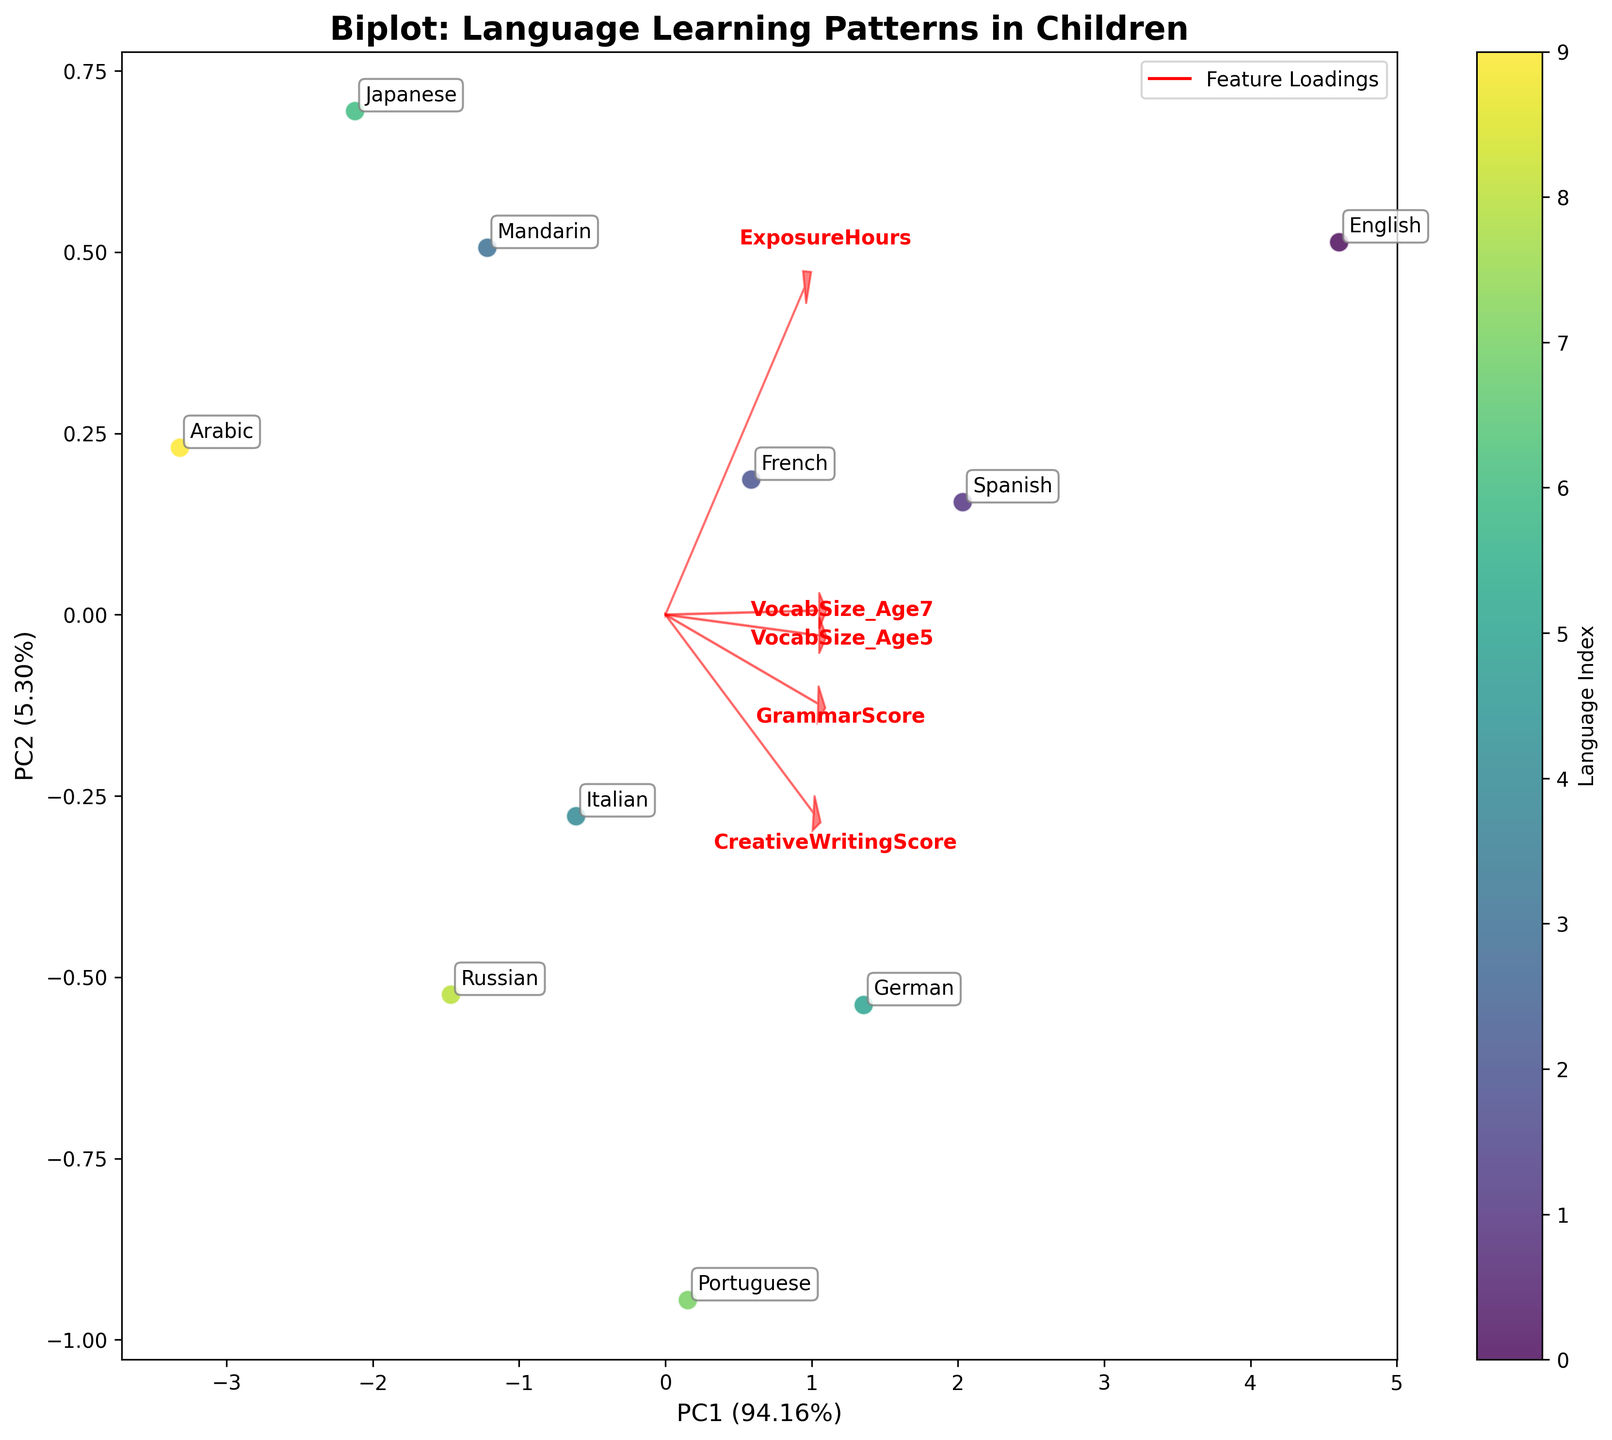what is the title of the figure? The title is located at the top of the figure, which describes the overall content or main point of the visual. It is written in bold for emphasis.
Answer: Biplot: Language Learning Patterns in Children Which language has the highest value on PC1? By observing the x-axis (PC1), identify the data point that is farthest to the right. The label for this data point reveals the language.
Answer: English What is the percentage of variance explained by PC1 and PC2 altogether? Sum the percentages shown in the axis labels for PC1 and PC2. PC1 and PC2 labels provide variance percentages.
Answer: 58.54% How are GrammarScore and CreativeWritingScore related according to the biplot loadings? Follow the arrows representing the GrammarScore and CreativeWritingScore loadings. See if they point in similar or different directions to understand their correlation.
Answer: Positively Correlated Which languages show a lower value in PC2 according to the Biplot? Check the y-axis (PC2), and identify labels at the bottom-most part for negative PC2 values.
Answer: Arabic and Japanese Which feature contributes the most to PC1? Examine the lengths of the arrows representing loadings for PC1. The longest arrow towards the x-axis has the maximum contribution.
Answer: ExposureHours How much variance is explained by the second principal component (PC2)? Look at the y-axis label. The percentage indicating the explained variance by PC2 is presented there.
Answer: 23.48% What can be inferred about Mandarin and Russian based on their positions in the biplot? Compare the positions of Mandarin and Russian data points along PC1 and PC2. Determine similarities or differences in their PCA scores.
Answer: Similar PC1, different PC2 Do VocabSize_Age5 and VocabSize_Age7 load similarly on the principal components? Review the direction and length of the arrows for VocabSize_Age5 and VocabSize_Age7. Check if they align closely, indicating a similar loading.
Answer: Yes 